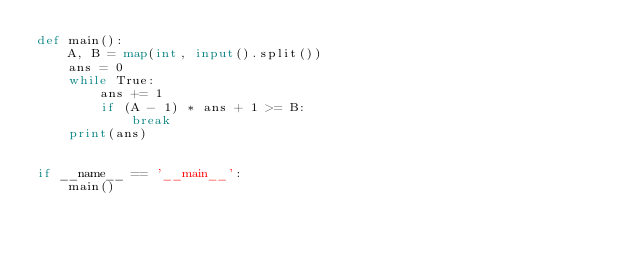Convert code to text. <code><loc_0><loc_0><loc_500><loc_500><_Python_>def main():
    A, B = map(int, input().split())
    ans = 0
    while True:
        ans += 1
        if (A - 1) * ans + 1 >= B:
            break
    print(ans)


if __name__ == '__main__':
    main()
</code> 